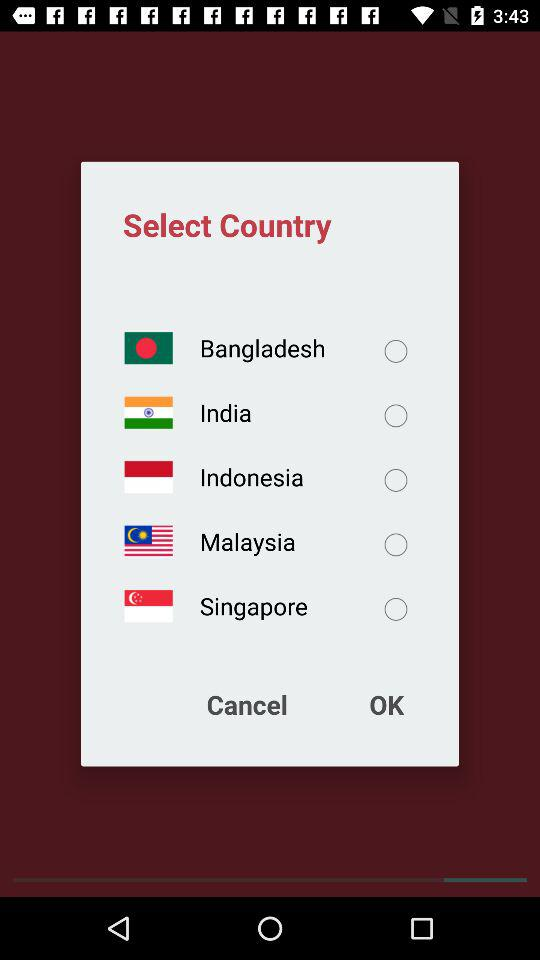How many countries are available to select?
Answer the question using a single word or phrase. 5 